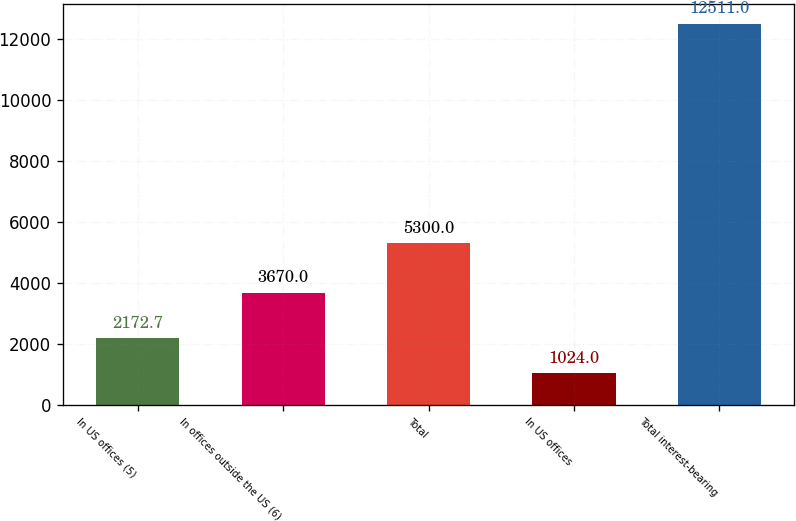Convert chart. <chart><loc_0><loc_0><loc_500><loc_500><bar_chart><fcel>In US offices (5)<fcel>In offices outside the US (6)<fcel>Total<fcel>In US offices<fcel>Total interest-bearing<nl><fcel>2172.7<fcel>3670<fcel>5300<fcel>1024<fcel>12511<nl></chart> 